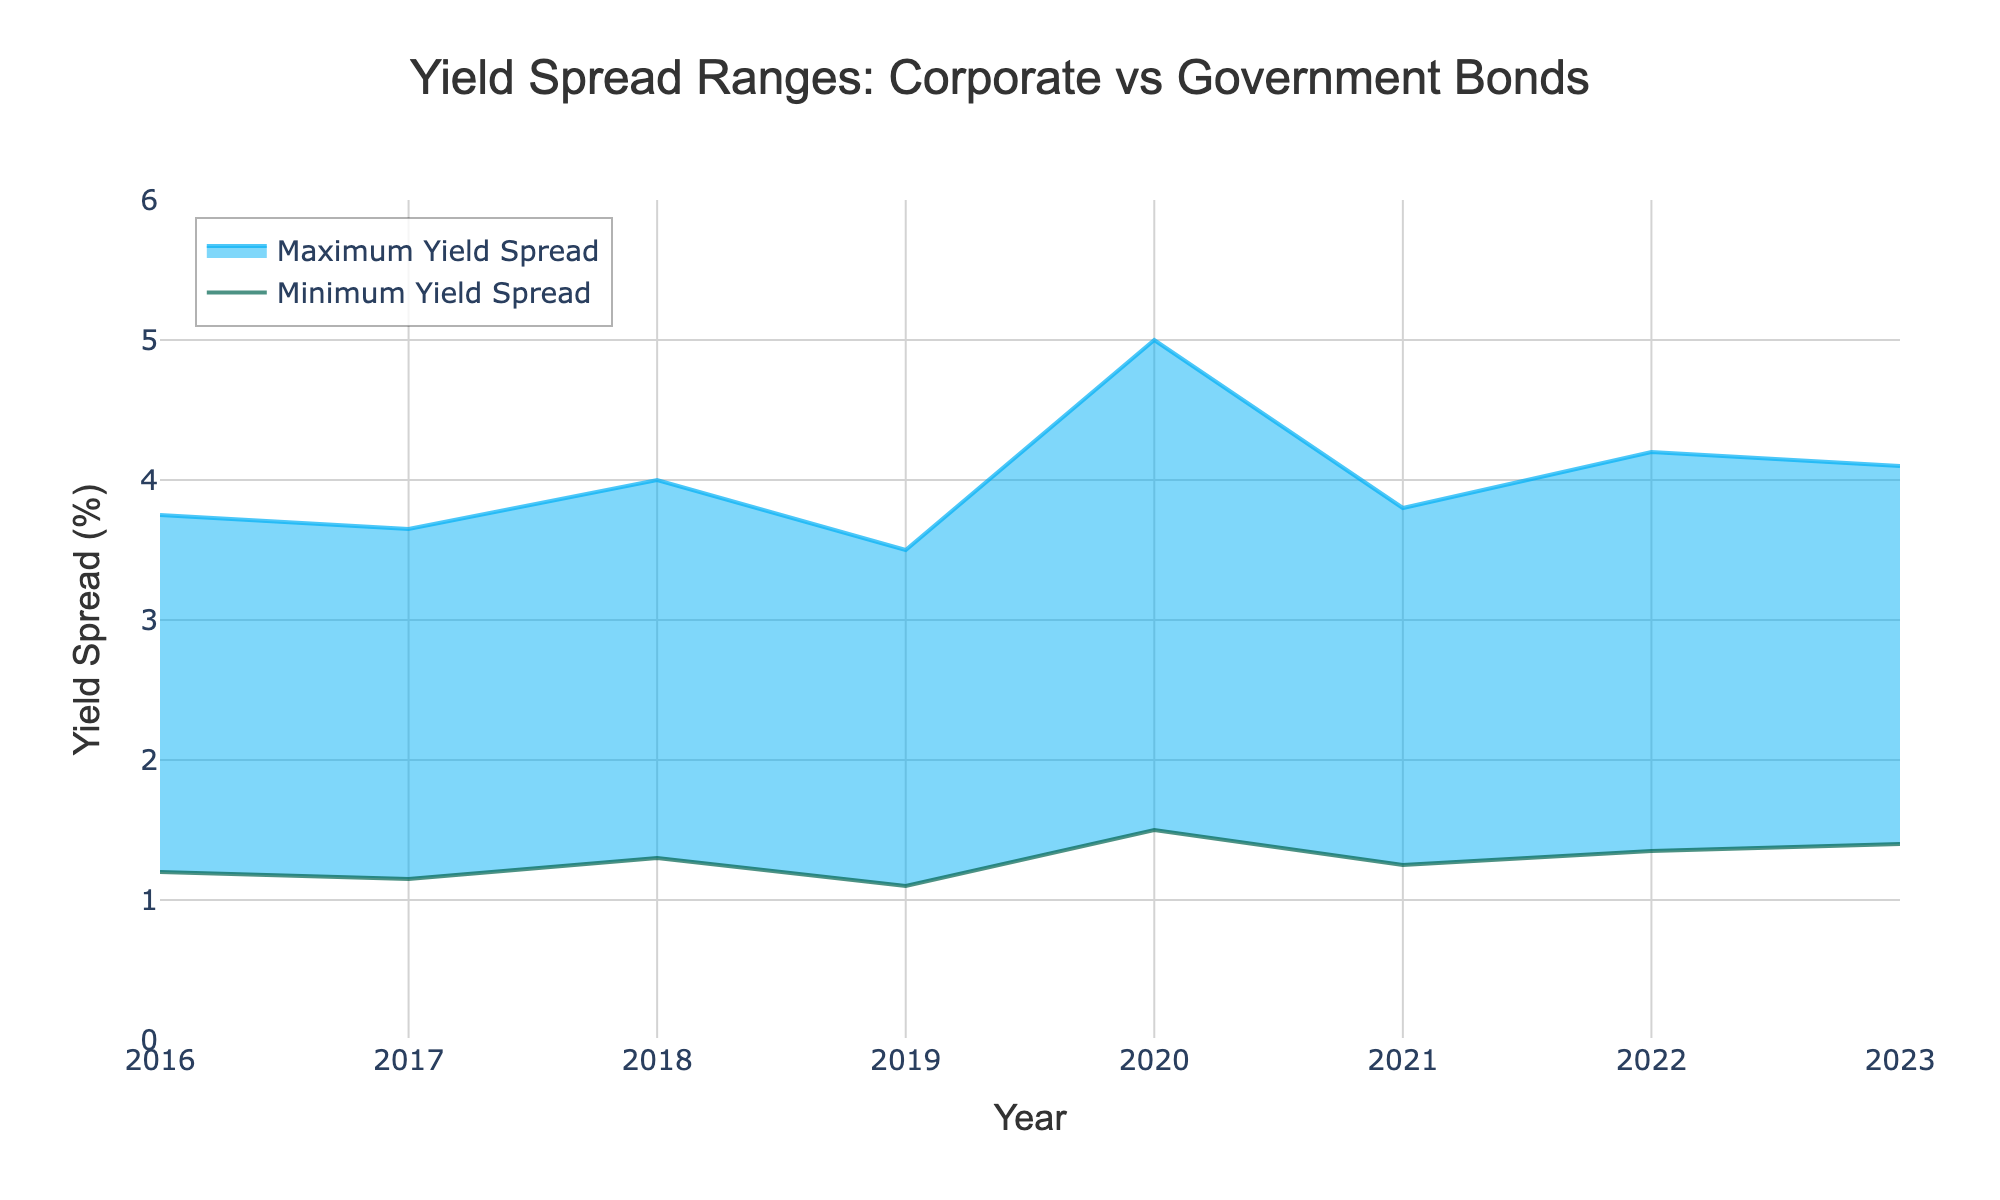What is the title of the figure? The title is prominently displayed at the top center of the figure.
Answer: Yield Spread Ranges: Corporate vs Government Bonds What range is displayed on the y-axis? The y-axis range is indicated by the scale on the left side of the chart, starting from 0 to 6.
Answer: 0 to 6 Which year has the lowest maximum yield spread? By examining the upper boundary of the shaded area for each year, 2019 has the lowest maximum yield spread.
Answer: 2019 What was the maximum yield spread in 2018? Locate the upper edge of the shaded area for 2018, which reaches up to 4.00.
Answer: 4.00 What is the trend in the minimum yield spread from 2016 to 2023? Follow the line representing the minimum yield spread from 2016 to 2023; it shows a generally upward trend with some fluctuations.
Answer: Generally upward Which year experienced the widest yield spread range? Compare the distances between the minimum and maximum yield spreads for each year; 2020 has the widest range.
Answer: 2020 How did the yield spread range change from 2021 to 2022? Observe the shaded area for both years; the maximum yield spread increased from 3.80 to 4.20 and the minimum yield spread increased from 1.25 to 1.35, making the range wider in 2022.
Answer: It widened In which year was the yield spread range the narrowest? The narrowest range can be identified by the smallest vertical distance between the minimum and maximum yield spreads for each year; 2019 has the narrowest range.
Answer: 2019 How did the maximum yield spread change from 2017 to 2018? Compare the maximum yield spread in 2017 (3.65) with that in 2018 (4.00); it increased by 0.35.
Answer: It increased What is the average maximum yield spread over the seven years? Calculate the average of the maximum yield spreads from 2016 to 2023: (3.75 + 3.65 + 4.00 + 3.50 + 5.00 + 3.80 + 4.20 + 4.10) / 8.
Answer: 3.88 